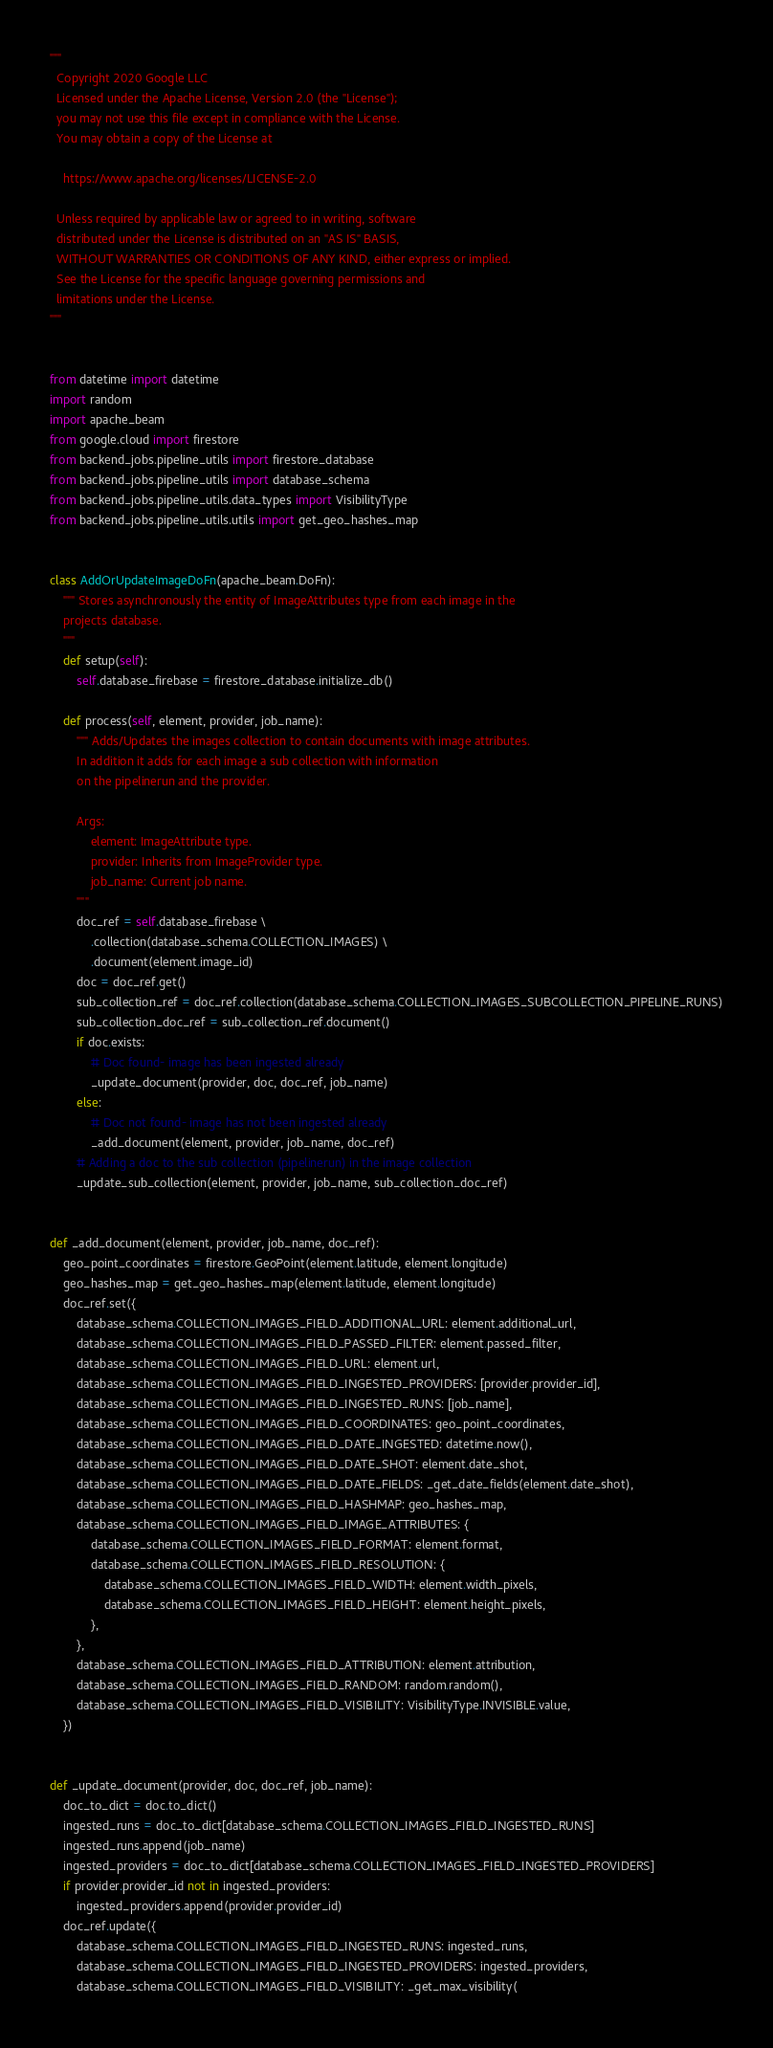Convert code to text. <code><loc_0><loc_0><loc_500><loc_500><_Python_>"""
  Copyright 2020 Google LLC
  Licensed under the Apache License, Version 2.0 (the "License");
  you may not use this file except in compliance with the License.
  You may obtain a copy of the License at

    https://www.apache.org/licenses/LICENSE-2.0

  Unless required by applicable law or agreed to in writing, software
  distributed under the License is distributed on an "AS IS" BASIS,
  WITHOUT WARRANTIES OR CONDITIONS OF ANY KIND, either express or implied.
  See the License for the specific language governing permissions and
  limitations under the License.
"""


from datetime import datetime
import random
import apache_beam
from google.cloud import firestore
from backend_jobs.pipeline_utils import firestore_database
from backend_jobs.pipeline_utils import database_schema
from backend_jobs.pipeline_utils.data_types import VisibilityType
from backend_jobs.pipeline_utils.utils import get_geo_hashes_map


class AddOrUpdateImageDoFn(apache_beam.DoFn):
    """ Stores asynchronously the entity of ImageAttributes type from each image in the
    projects database.
    """
    def setup(self):
        self.database_firebase = firestore_database.initialize_db()

    def process(self, element, provider, job_name):
        """ Adds/Updates the images collection to contain documents with image attributes.
        In addition it adds for each image a sub collection with information
        on the pipelinerun and the provider.

        Args:
            element: ImageAttribute type.
            provider: Inherits from ImageProvider type.
            job_name: Current job name.
        """
        doc_ref = self.database_firebase \
            .collection(database_schema.COLLECTION_IMAGES) \
            .document(element.image_id)
        doc = doc_ref.get()
        sub_collection_ref = doc_ref.collection(database_schema.COLLECTION_IMAGES_SUBCOLLECTION_PIPELINE_RUNS)
        sub_collection_doc_ref = sub_collection_ref.document()
        if doc.exists:
            # Doc found- image has been ingested already
            _update_document(provider, doc, doc_ref, job_name)
        else:
            # Doc not found- image has not been ingested already
            _add_document(element, provider, job_name, doc_ref)
        # Adding a doc to the sub collection (pipelinerun) in the image collection
        _update_sub_collection(element, provider, job_name, sub_collection_doc_ref)


def _add_document(element, provider, job_name, doc_ref):
    geo_point_coordinates = firestore.GeoPoint(element.latitude, element.longitude)
    geo_hashes_map = get_geo_hashes_map(element.latitude, element.longitude)
    doc_ref.set({
        database_schema.COLLECTION_IMAGES_FIELD_ADDITIONAL_URL: element.additional_url,
        database_schema.COLLECTION_IMAGES_FIELD_PASSED_FILTER: element.passed_filter,
        database_schema.COLLECTION_IMAGES_FIELD_URL: element.url,
        database_schema.COLLECTION_IMAGES_FIELD_INGESTED_PROVIDERS: [provider.provider_id],
        database_schema.COLLECTION_IMAGES_FIELD_INGESTED_RUNS: [job_name],
        database_schema.COLLECTION_IMAGES_FIELD_COORDINATES: geo_point_coordinates,
        database_schema.COLLECTION_IMAGES_FIELD_DATE_INGESTED: datetime.now(),
        database_schema.COLLECTION_IMAGES_FIELD_DATE_SHOT: element.date_shot,
        database_schema.COLLECTION_IMAGES_FIELD_DATE_FIELDS: _get_date_fields(element.date_shot),
        database_schema.COLLECTION_IMAGES_FIELD_HASHMAP: geo_hashes_map,
        database_schema.COLLECTION_IMAGES_FIELD_IMAGE_ATTRIBUTES: {
            database_schema.COLLECTION_IMAGES_FIELD_FORMAT: element.format,
            database_schema.COLLECTION_IMAGES_FIELD_RESOLUTION: {
                database_schema.COLLECTION_IMAGES_FIELD_WIDTH: element.width_pixels,
                database_schema.COLLECTION_IMAGES_FIELD_HEIGHT: element.height_pixels,
            },
        },
        database_schema.COLLECTION_IMAGES_FIELD_ATTRIBUTION: element.attribution,
        database_schema.COLLECTION_IMAGES_FIELD_RANDOM: random.random(),
        database_schema.COLLECTION_IMAGES_FIELD_VISIBILITY: VisibilityType.INVISIBLE.value,
    })


def _update_document(provider, doc, doc_ref, job_name):
    doc_to_dict = doc.to_dict()
    ingested_runs = doc_to_dict[database_schema.COLLECTION_IMAGES_FIELD_INGESTED_RUNS]
    ingested_runs.append(job_name)
    ingested_providers = doc_to_dict[database_schema.COLLECTION_IMAGES_FIELD_INGESTED_PROVIDERS]
    if provider.provider_id not in ingested_providers:
        ingested_providers.append(provider.provider_id)
    doc_ref.update({
        database_schema.COLLECTION_IMAGES_FIELD_INGESTED_RUNS: ingested_runs,
        database_schema.COLLECTION_IMAGES_FIELD_INGESTED_PROVIDERS: ingested_providers,
        database_schema.COLLECTION_IMAGES_FIELD_VISIBILITY: _get_max_visibility(</code> 